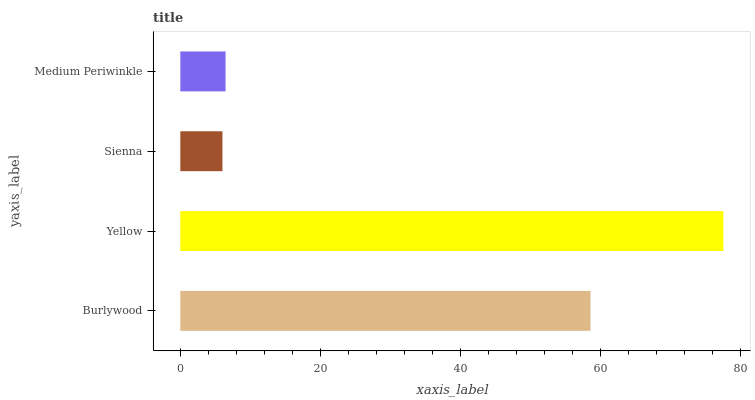Is Sienna the minimum?
Answer yes or no. Yes. Is Yellow the maximum?
Answer yes or no. Yes. Is Yellow the minimum?
Answer yes or no. No. Is Sienna the maximum?
Answer yes or no. No. Is Yellow greater than Sienna?
Answer yes or no. Yes. Is Sienna less than Yellow?
Answer yes or no. Yes. Is Sienna greater than Yellow?
Answer yes or no. No. Is Yellow less than Sienna?
Answer yes or no. No. Is Burlywood the high median?
Answer yes or no. Yes. Is Medium Periwinkle the low median?
Answer yes or no. Yes. Is Medium Periwinkle the high median?
Answer yes or no. No. Is Sienna the low median?
Answer yes or no. No. 